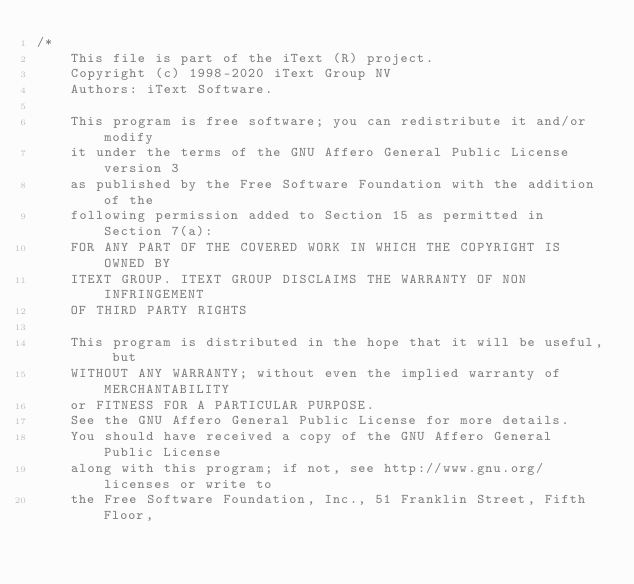Convert code to text. <code><loc_0><loc_0><loc_500><loc_500><_C#_>/*
    This file is part of the iText (R) project.
    Copyright (c) 1998-2020 iText Group NV
    Authors: iText Software.

    This program is free software; you can redistribute it and/or modify
    it under the terms of the GNU Affero General Public License version 3
    as published by the Free Software Foundation with the addition of the
    following permission added to Section 15 as permitted in Section 7(a):
    FOR ANY PART OF THE COVERED WORK IN WHICH THE COPYRIGHT IS OWNED BY
    ITEXT GROUP. ITEXT GROUP DISCLAIMS THE WARRANTY OF NON INFRINGEMENT
    OF THIRD PARTY RIGHTS
    
    This program is distributed in the hope that it will be useful, but
    WITHOUT ANY WARRANTY; without even the implied warranty of MERCHANTABILITY
    or FITNESS FOR A PARTICULAR PURPOSE.
    See the GNU Affero General Public License for more details.
    You should have received a copy of the GNU Affero General Public License
    along with this program; if not, see http://www.gnu.org/licenses or write to
    the Free Software Foundation, Inc., 51 Franklin Street, Fifth Floor,</code> 